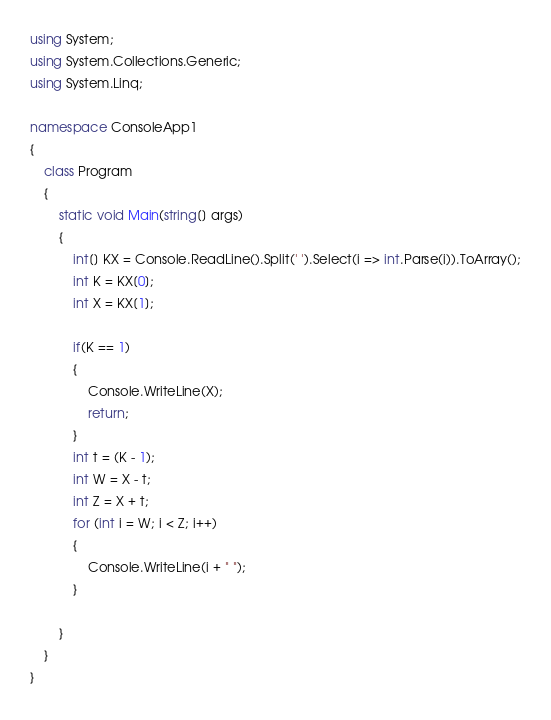Convert code to text. <code><loc_0><loc_0><loc_500><loc_500><_C#_>using System;
using System.Collections.Generic;
using System.Linq;

namespace ConsoleApp1
{
    class Program
    {
        static void Main(string[] args)
        {
            int[] KX = Console.ReadLine().Split(' ').Select(i => int.Parse(i)).ToArray();
            int K = KX[0];
            int X = KX[1];
            
            if(K == 1)
            {
                Console.WriteLine(X);
                return;
            }
            int t = (K - 1);
            int W = X - t;
            int Z = X + t;
            for (int i = W; i < Z; i++)
            {
                Console.WriteLine(i + " ");
            }

        }
    }
}</code> 